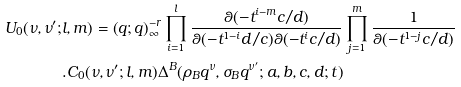Convert formula to latex. <formula><loc_0><loc_0><loc_500><loc_500>U _ { 0 } ( \nu , \nu ^ { \prime } ; & l , m ) = \left ( q ; q \right ) _ { \infty } ^ { - r } \prod _ { i = 1 } ^ { l } \frac { \theta ( - t ^ { i - m } c / d ) } { \theta ( - t ^ { 1 - i } d / c ) \theta ( - t ^ { i } c / d ) } \prod _ { j = 1 } ^ { m } \frac { 1 } { \theta ( - t ^ { 1 - j } c / d ) } \\ & . C _ { 0 } ( \nu , \nu ^ { \prime } ; l , m ) \Delta ^ { B } ( \rho _ { B } q ^ { \nu } , \sigma _ { B } q ^ { \nu ^ { \prime } } ; a , b , c , d ; t ) \\</formula> 